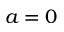Convert formula to latex. <formula><loc_0><loc_0><loc_500><loc_500>a = 0</formula> 